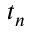Convert formula to latex. <formula><loc_0><loc_0><loc_500><loc_500>t _ { n }</formula> 